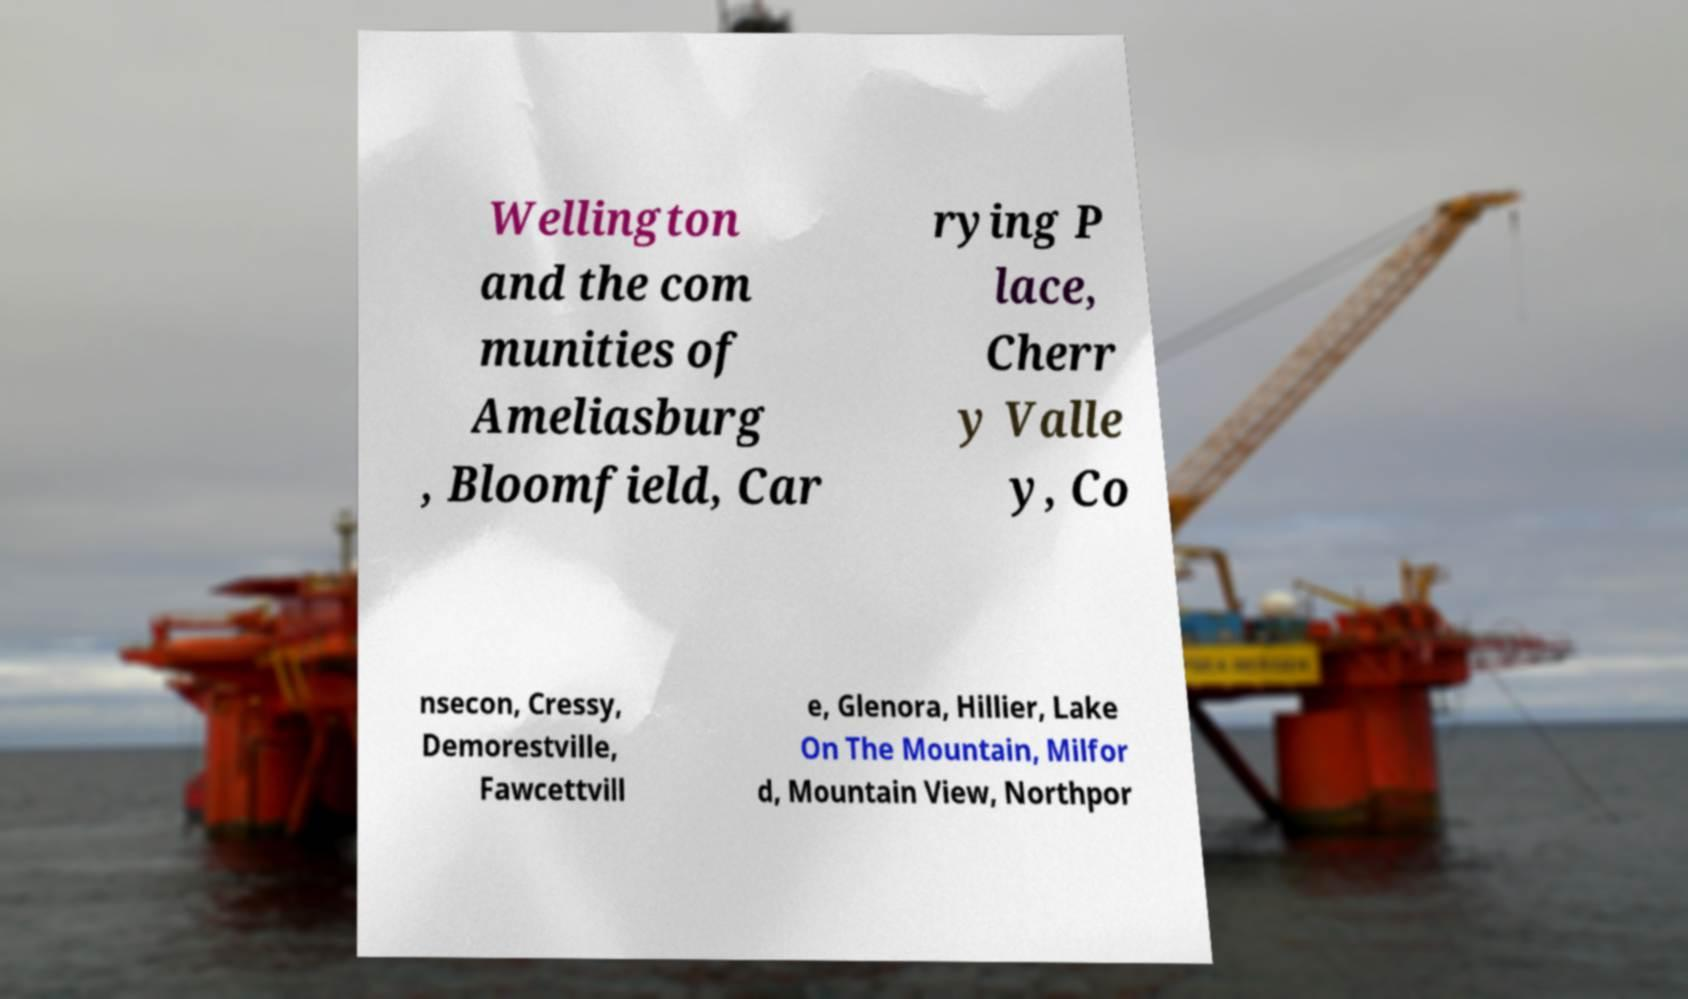Can you read and provide the text displayed in the image?This photo seems to have some interesting text. Can you extract and type it out for me? Wellington and the com munities of Ameliasburg , Bloomfield, Car rying P lace, Cherr y Valle y, Co nsecon, Cressy, Demorestville, Fawcettvill e, Glenora, Hillier, Lake On The Mountain, Milfor d, Mountain View, Northpor 